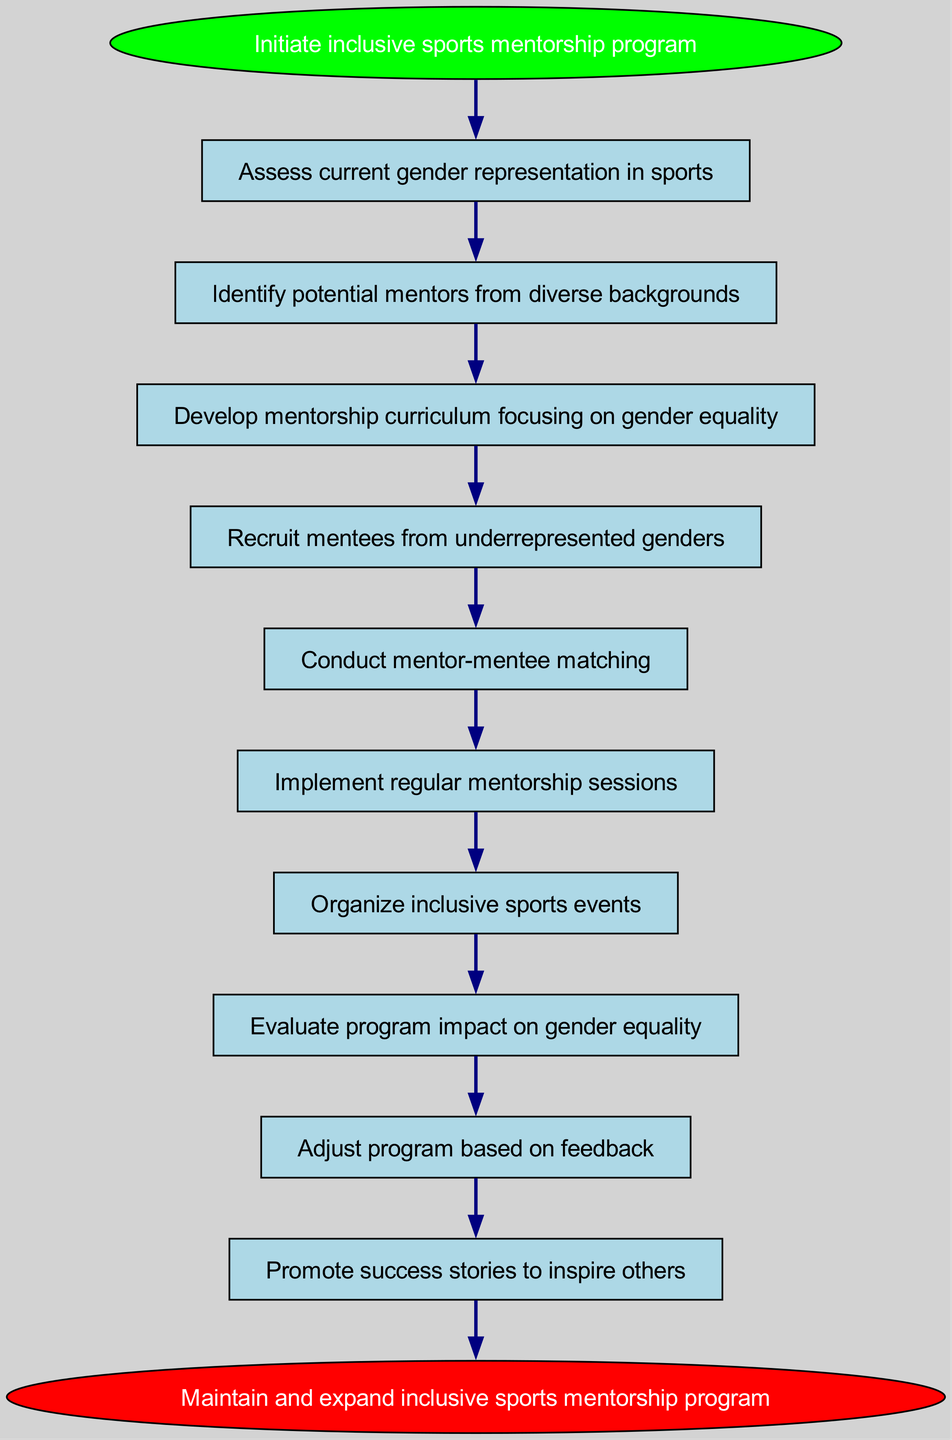What is the first step in the program? The diagram indicates that the first step is labeled as “1” and it is “Assess current gender representation in sports.”
Answer: Assess current gender representation in sports How many total steps are there in the program? The diagram outlines ten steps before reaching the end node, indicating a total of ten steps.
Answer: 10 What happens after developing the mentorship curriculum? According to the flowchart, after developing the mentorship curriculum, the next step is to “Recruit mentees from underrepresented genders.”
Answer: Recruit mentees from underrepresented genders What is the purpose of the last step in the program? The last step in the diagram focuses on promoting success stories to inspire others, which is about sharing positive outcomes and motivating further involvement.
Answer: Promote success stories to inspire others Which step is directly connected to organizing inclusive sports events? The diagram shows a direct connection to step “7,” which is “Organize inclusive sports events” that follows after “Implement regular mentorship sessions.”
Answer: Implement regular mentorship sessions What two steps lead to the evaluation of the program's impact? The steps leading to the evaluation of the program's impact are “Organize inclusive sports events” and “Evaluate program impact on gender equality.” Hence, “7” and “8” are the two connected steps.
Answer: Organize inclusive sports events; Evaluate program impact on gender equality What step involves mentor-mentee matching? The diagram specifies that mentor-mentee matching occurs in step “5,” which is labeled as “Conduct mentor-mentee matching.”
Answer: Conduct mentor-mentee matching What needs to be adjusted based on the program's feedback? The diagram indicates that adjustments to the program should be made based on the feedback collected, specifically highlighted in step “9,” which is “Adjust program based on feedback.”
Answer: Adjust program based on feedback What color is the start node in the diagram? The start node, which indicates the beginning of the program, is represented in green color as per the visual attributes outlined in the diagram.
Answer: Green 